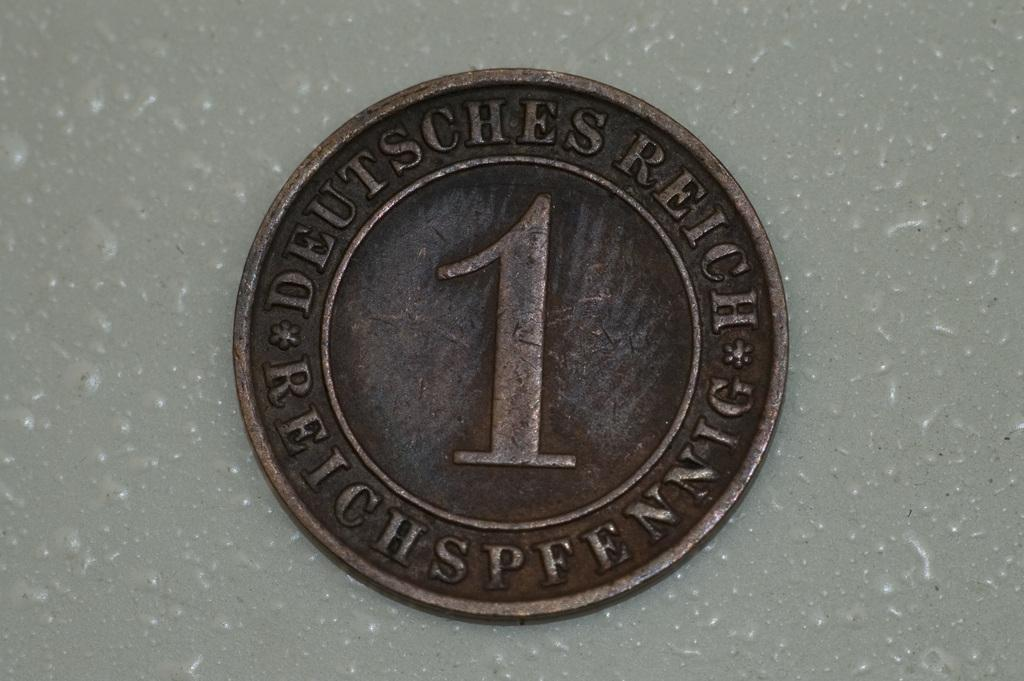<image>
Relay a brief, clear account of the picture shown. A one pfennig German coin is seen in close up. 